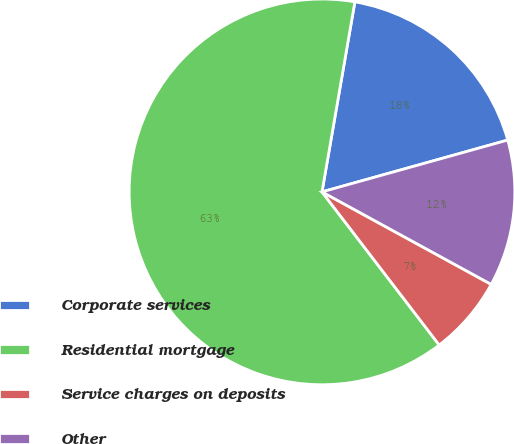<chart> <loc_0><loc_0><loc_500><loc_500><pie_chart><fcel>Corporate services<fcel>Residential mortgage<fcel>Service charges on deposits<fcel>Other<nl><fcel>17.94%<fcel>63.12%<fcel>6.64%<fcel>12.29%<nl></chart> 